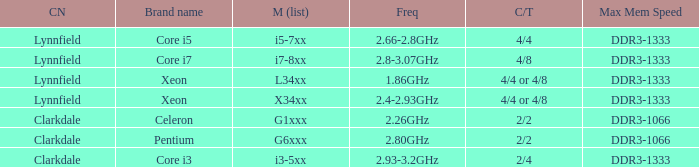What is the maximum memory speed for frequencies between 2.93-3.2ghz? DDR3-1333. 